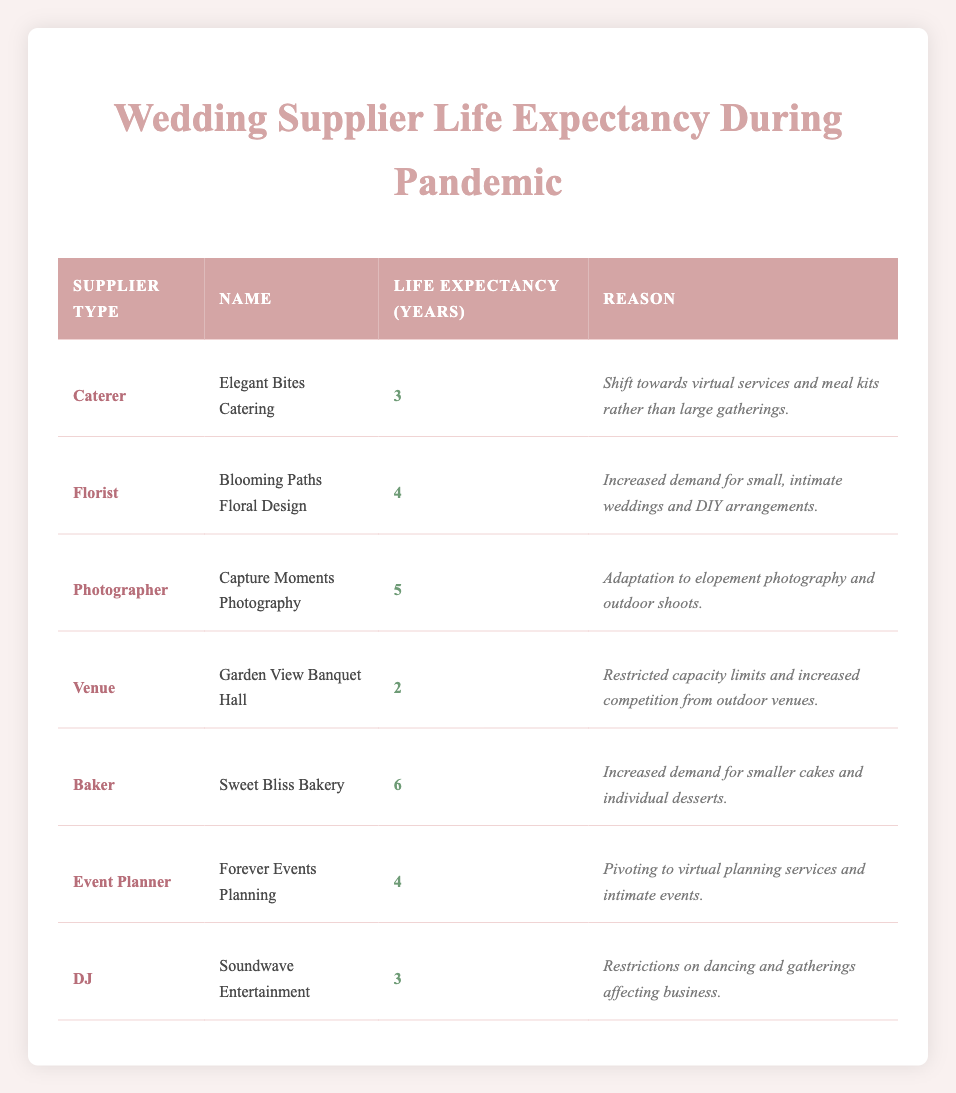What is the life expectancy of the Photographer supplier? According to the table, the life expectancy of the Photographer supplier, "Capture Moments Photography," is listed as 5 years.
Answer: 5 years Which wedding service has the longest life expectancy during the pandemic? Looking at the table, the Baker supplier, "Sweet Bliss Bakery," has the longest life expectancy at 6 years, as it is the highest value listed under life expectancy.
Answer: 6 years Is the life expectancy of Event Planners higher than that of DJs? The table shows that the life expectancy of Event Planners, "Forever Events Planning," is 4 years, while the life expectancy of DJs, "Soundwave Entertainment," is 3 years. Since 4 is greater than 3, the statement is true.
Answer: Yes What is the average life expectancy of all suppliers in the table? To find the average, we add all the life expectancies: 3 + 4 + 5 + 2 + 6 + 4 + 3 = 27. There are 7 suppliers, so we divide the total by 7: 27 / 7 = 3.857 (approximately 3.86).
Answer: Approximately 3.86 years Does the Florist have a higher life expectancy than the Venue supplier? The table states that the life expectancy of the Florist, "Blooming Paths Floral Design," is 4 years, while the Venue, "Garden View Banquet Hall," has a life expectancy of 2 years. Since 4 is greater than 2, the answer is true.
Answer: Yes Which supplier type has a life expectancy of 2 years, and what is the reason for this? The Venue supplier type, represented by "Garden View Banquet Hall," has a life expectancy of 2 years. The reason provided is restricted capacity limits and increased competition from outdoor venues.
Answer: Venue, reason: restricted capacity limits and competition How many suppliers have a life expectancy greater than 4 years? From the table, the suppliers with a life expectancy greater than 4 years are the Baker (6 years) and Photographer (5 years). Therefore, there are 2 suppliers with a life expectancy greater than 4 years.
Answer: 2 suppliers What is the total life expectancy of all suppliers combined? To determine the total life expectancy, add all values: 3 + 4 + 5 + 2 + 6 + 4 + 3 = 27 years. This total gives the combined life expectancy of all suppliers listed.
Answer: 27 years 